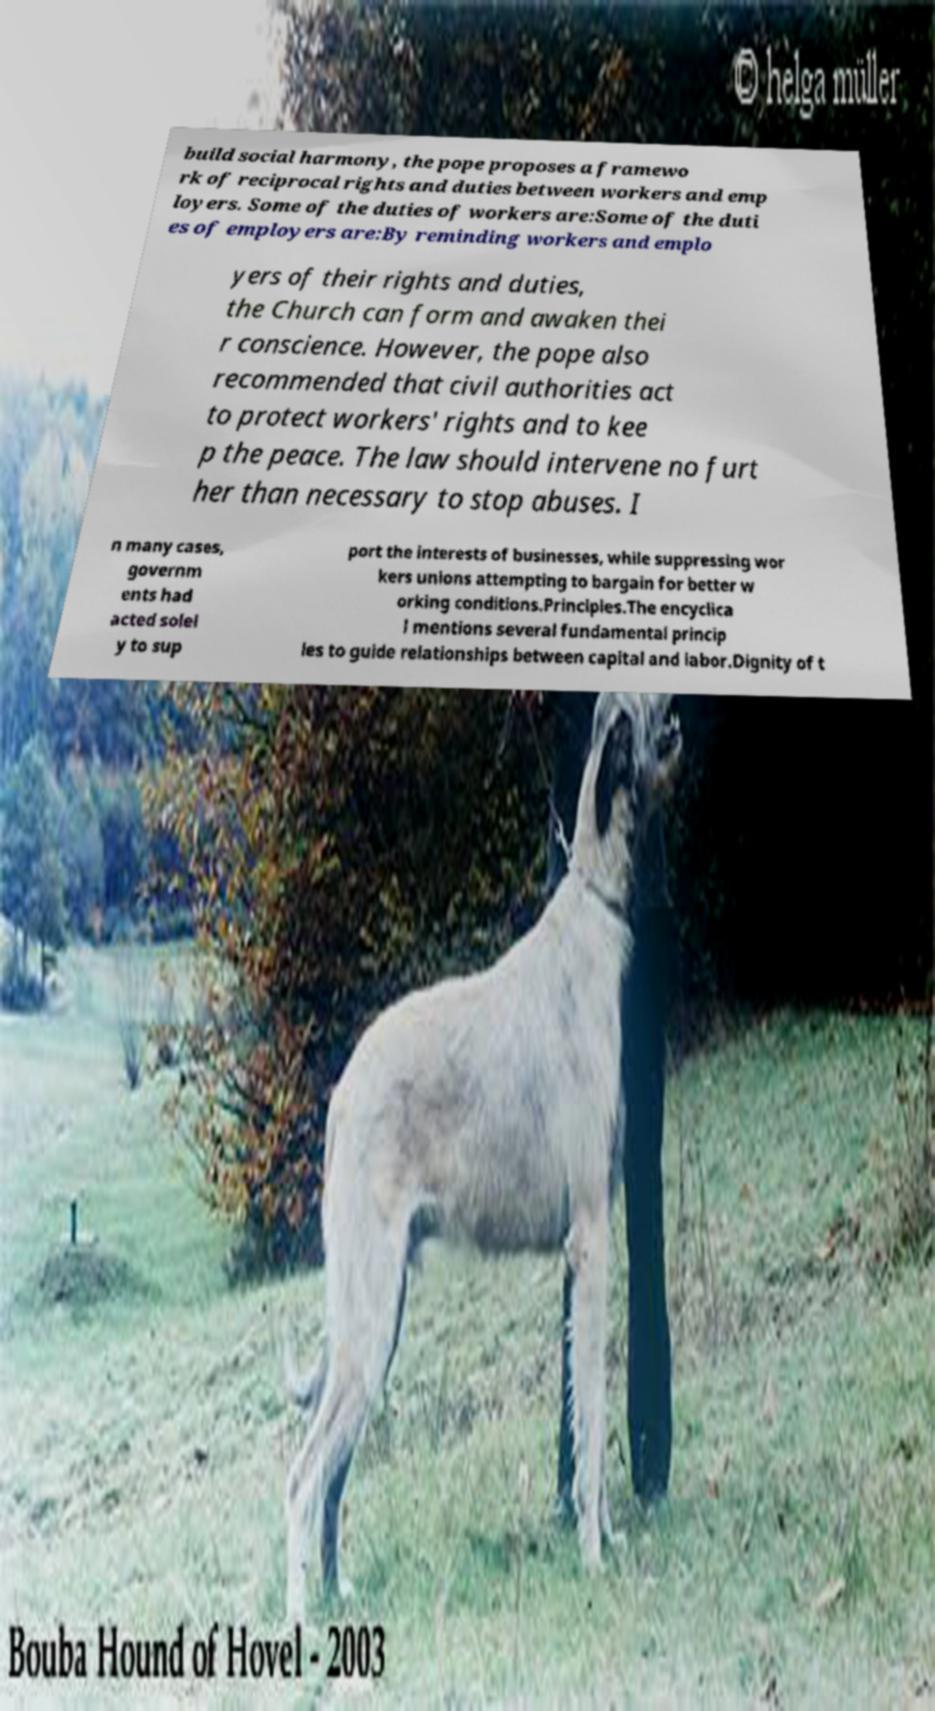Can you read and provide the text displayed in the image?This photo seems to have some interesting text. Can you extract and type it out for me? build social harmony, the pope proposes a framewo rk of reciprocal rights and duties between workers and emp loyers. Some of the duties of workers are:Some of the duti es of employers are:By reminding workers and emplo yers of their rights and duties, the Church can form and awaken thei r conscience. However, the pope also recommended that civil authorities act to protect workers' rights and to kee p the peace. The law should intervene no furt her than necessary to stop abuses. I n many cases, governm ents had acted solel y to sup port the interests of businesses, while suppressing wor kers unions attempting to bargain for better w orking conditions.Principles.The encyclica l mentions several fundamental princip les to guide relationships between capital and labor.Dignity of t 